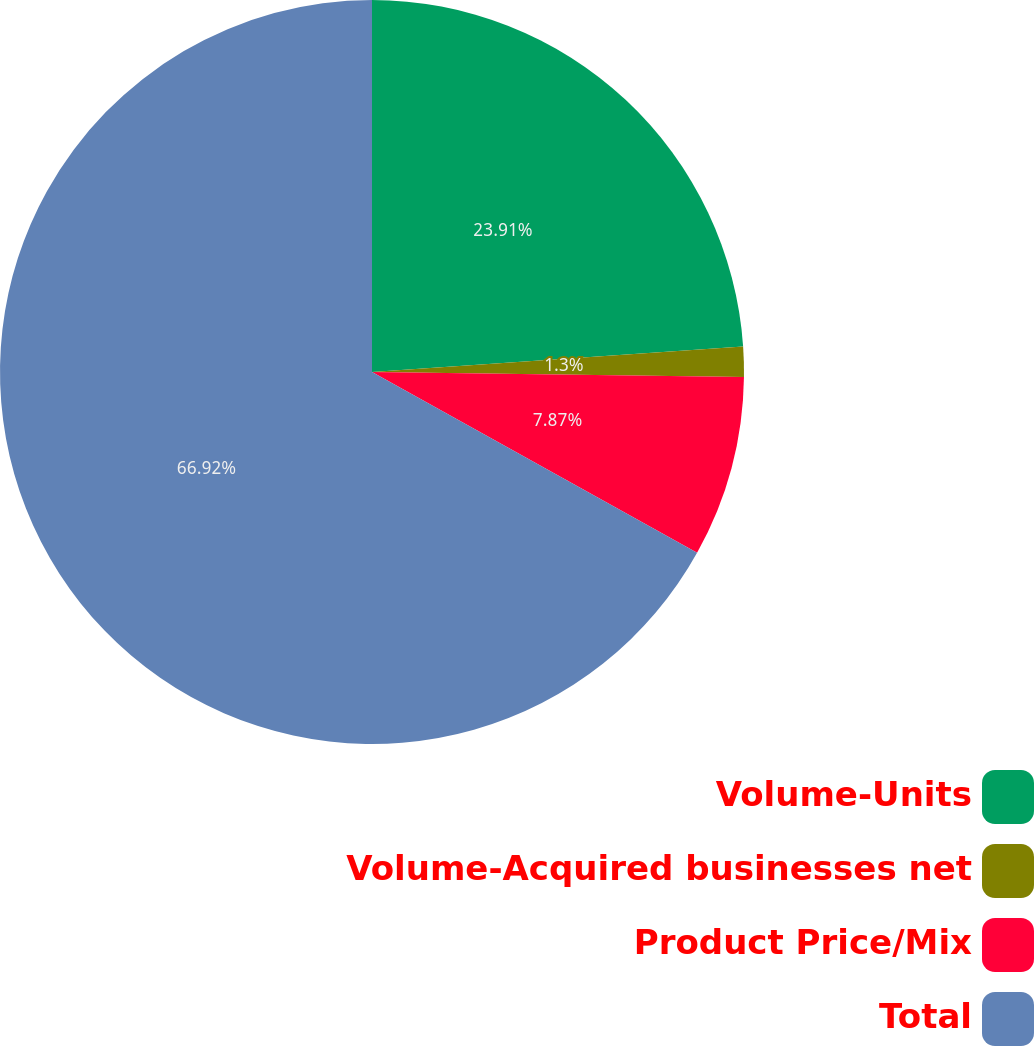Convert chart. <chart><loc_0><loc_0><loc_500><loc_500><pie_chart><fcel>Volume-Units<fcel>Volume-Acquired businesses net<fcel>Product Price/Mix<fcel>Total<nl><fcel>23.91%<fcel>1.3%<fcel>7.87%<fcel>66.92%<nl></chart> 